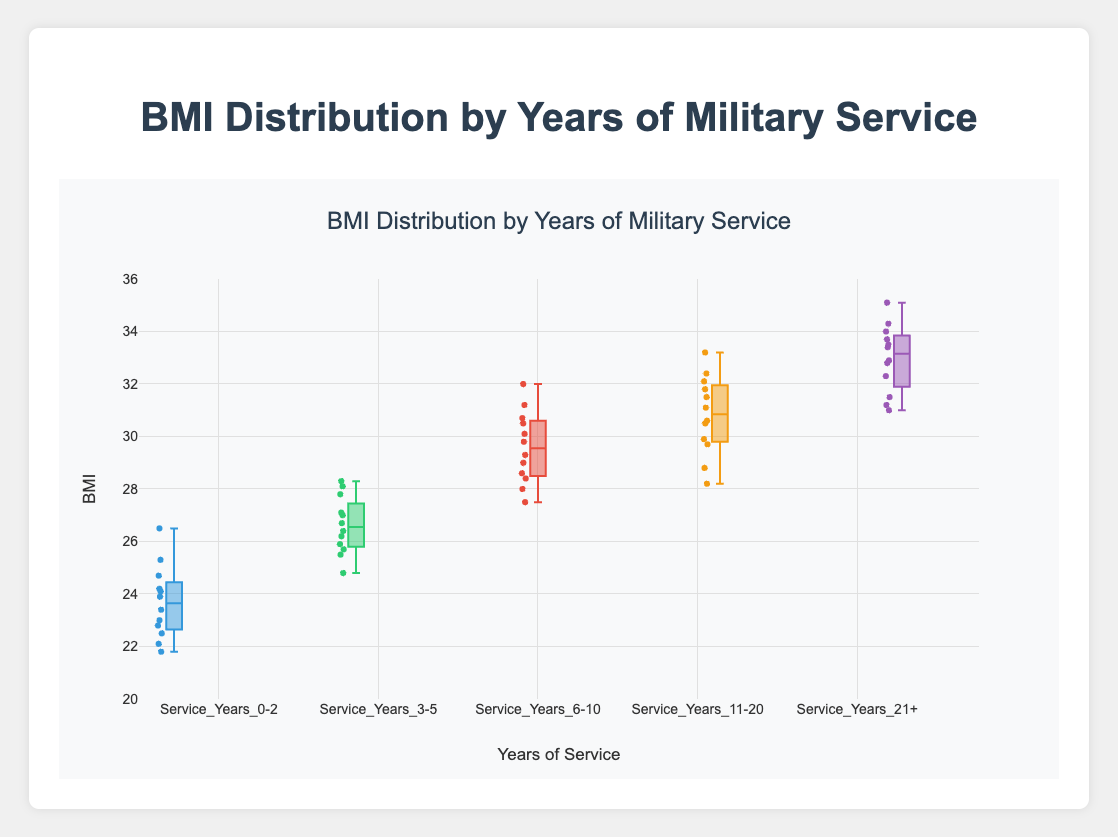What's the median BMI for each group? Refer to the figure and look at the line inside each box plot, which indicates the median value for each group.
Answer: 23.4, 26.4, 29.0, 30.6, 32.8 Which group has the highest median BMI? Identify the group with the highest line inside the box plot. The highest median value is in the group with 21+ years of service.
Answer: Service_Years_21+ What is the interquartile range (IQR) for the Service_Years_0-2 group? IQR is the difference between the 75th percentile and the 25th percentile. Find these values in the box plot for the Service_Years_0-2 group.
Answer: Approximately 24.2 – 22.5 = 1.7 How does the BMI variance change with years of military service? By comparing the spread of the boxes in the figure, one can observe that the boxes tend to get larger as years of service increase, indicating a higher variance.
Answer: Variance increases Which group has the largest range of BMI values? Compare the total spread (from the minimum to the maximum whiskers) for each box plot. The largest range is seen in the Service_Years_21+ group.
Answer: Service_Years_21+ Are there any outliers in the Service_Years_0-2 group? Outliers are typically represented by individual points outside the whiskers. Check if there are any individual points outside the box plot whiskers for the Service_Years_0-2 group.
Answer: No What is the overall trend in BMI with increasing years of military service? Observe the median line in each box plot, which shows an increasing trend from the Service_Years_0-2 group to the Service_Years_21+ group.
Answer: BMI increases Is there a group with overlapping interquartile ranges (IQR) with another group? Check if the boxes (IQR regions) for any groups overlap vertically. The IQRs of the Service_Years_6-10 and Service_Years_11-20 groups show some overlap.
Answer: Service_Years_6-10 and Service_Years_11-20 What's the whisker range for the Service_Years_11-20 group? Whiskers on a box plot extend to the smallest and largest values within 1.5 times the IQR from the lower and upper quartiles. Check the ends of the whiskers for the Service_Years_11-20 group.
Answer: Approximately 28.2 to 33.2 